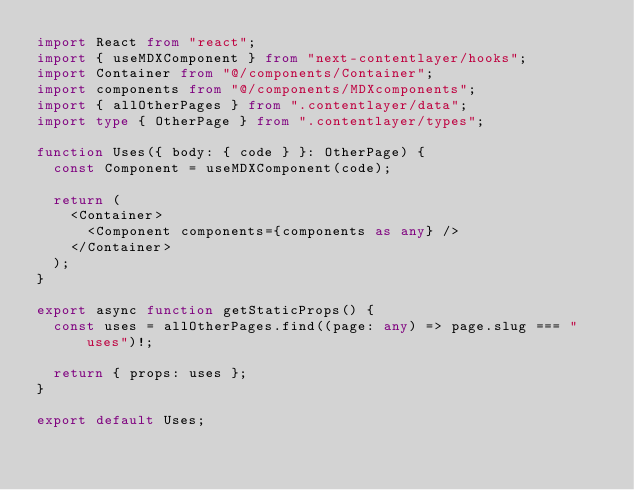<code> <loc_0><loc_0><loc_500><loc_500><_TypeScript_>import React from "react";
import { useMDXComponent } from "next-contentlayer/hooks";
import Container from "@/components/Container";
import components from "@/components/MDXcomponents";
import { allOtherPages } from ".contentlayer/data";
import type { OtherPage } from ".contentlayer/types";

function Uses({ body: { code } }: OtherPage) {
  const Component = useMDXComponent(code);

  return (
    <Container>
      <Component components={components as any} />
    </Container>
  );
}

export async function getStaticProps() {
  const uses = allOtherPages.find((page: any) => page.slug === "uses")!;

  return { props: uses };
}

export default Uses;
</code> 